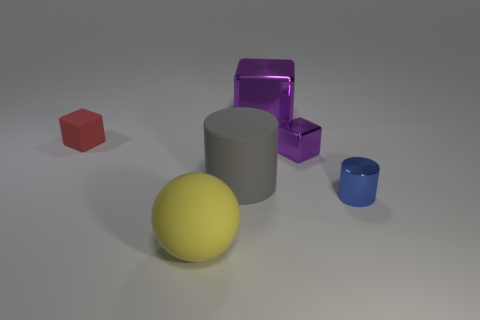Add 1 red cylinders. How many objects exist? 7 Subtract all spheres. How many objects are left? 5 Subtract all red rubber things. Subtract all blue objects. How many objects are left? 4 Add 4 large cubes. How many large cubes are left? 5 Add 4 big purple shiny cubes. How many big purple shiny cubes exist? 5 Subtract 0 brown balls. How many objects are left? 6 